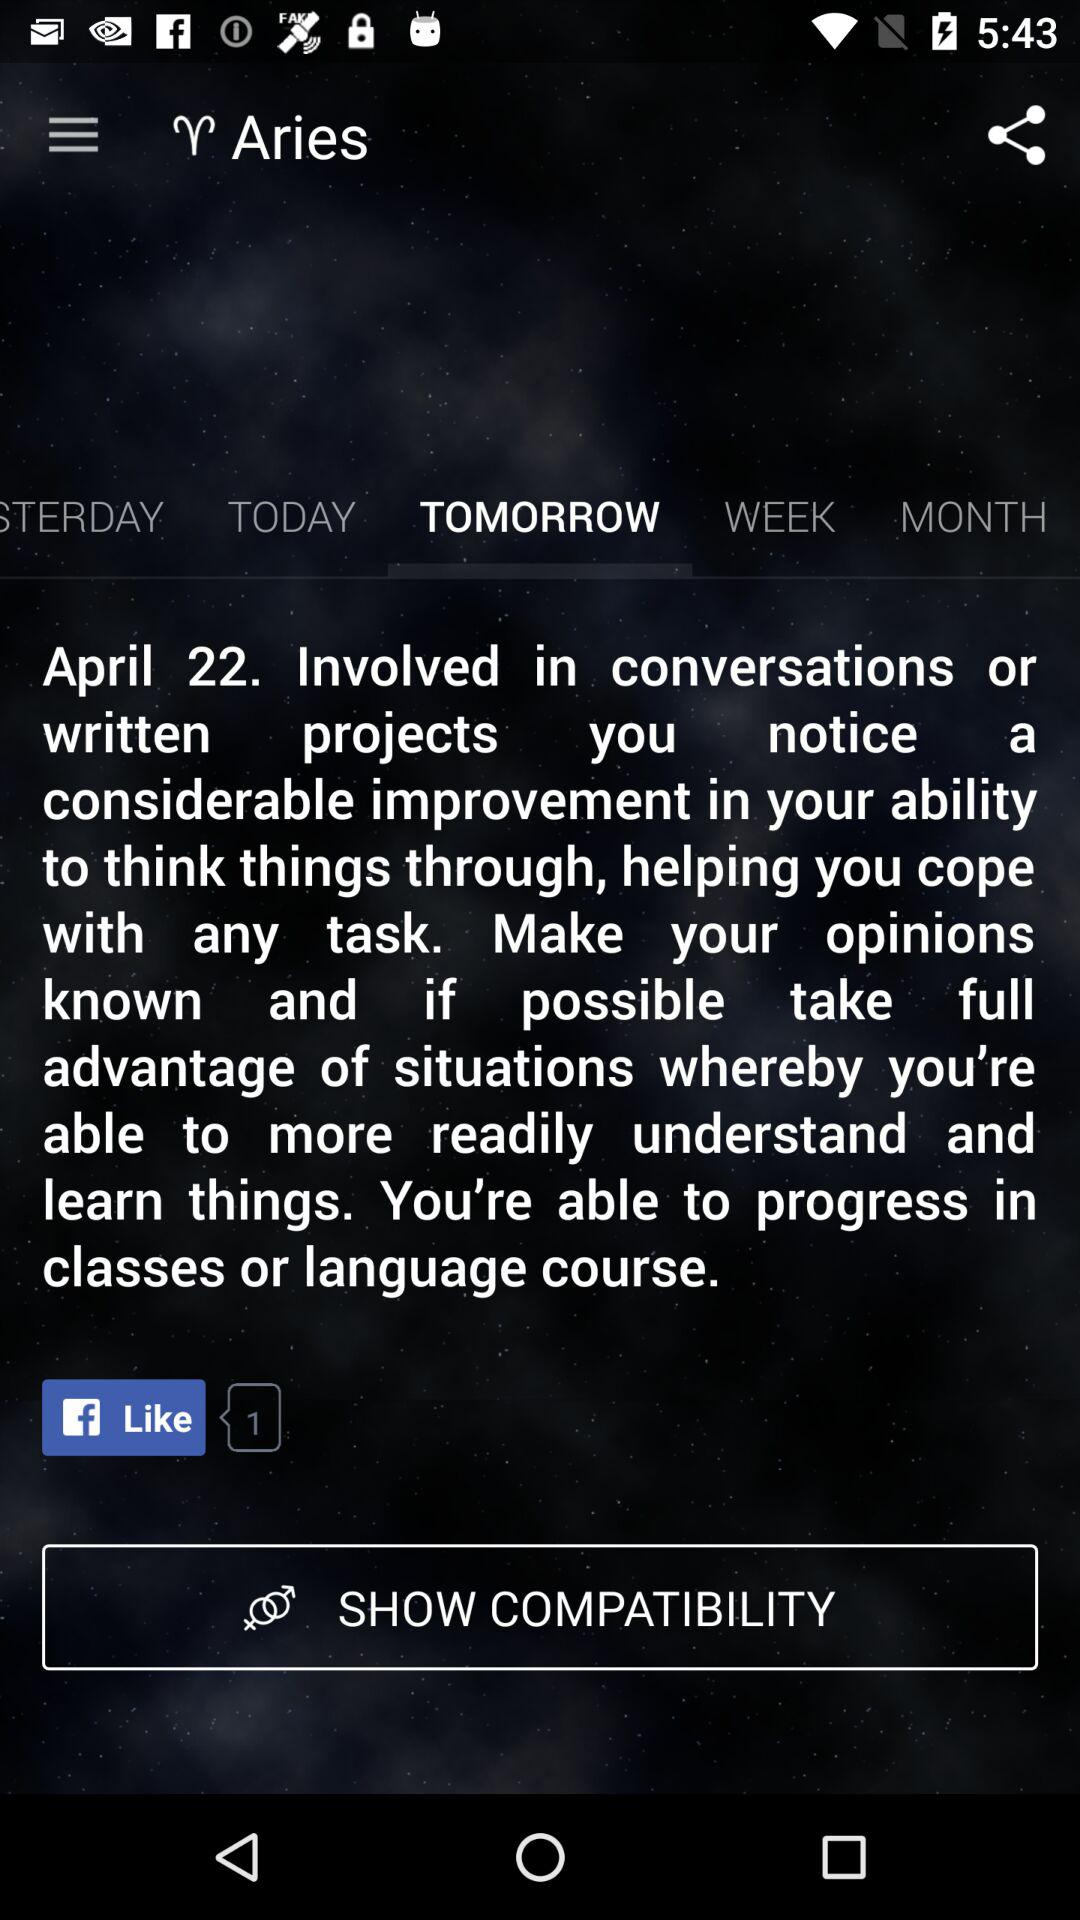What is the name of the zodiac sign? The name of the zodiac sign is Aries. 